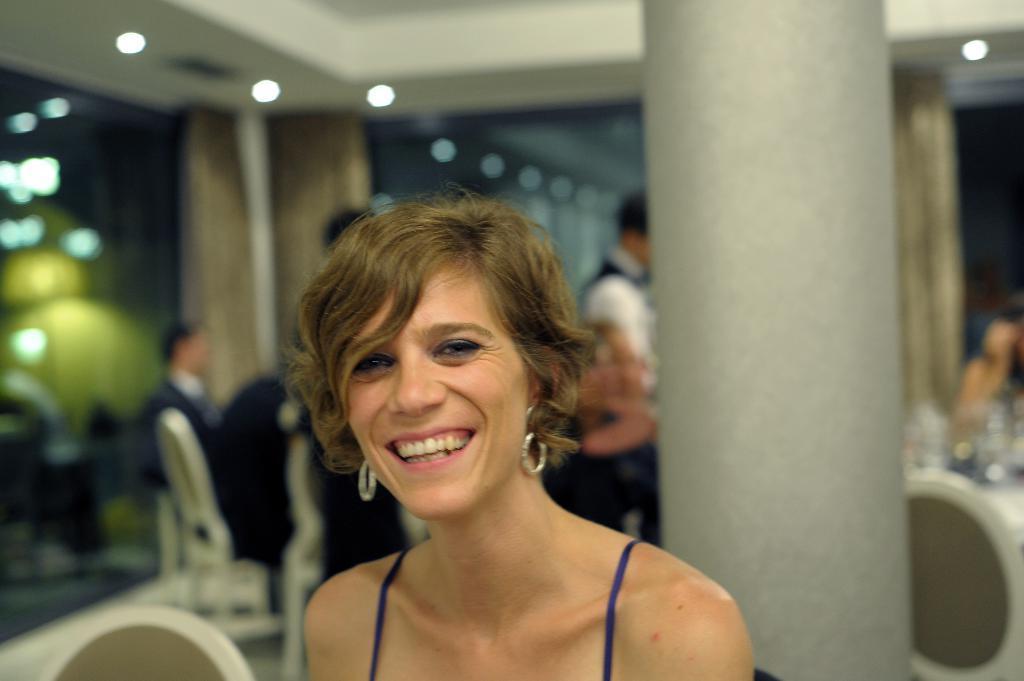Could you give a brief overview of what you see in this image? In this image in the front there is a woman smiling. In the center there is a pillar and the background seems to be blurred, there are persons in the back ground and there are objects. 